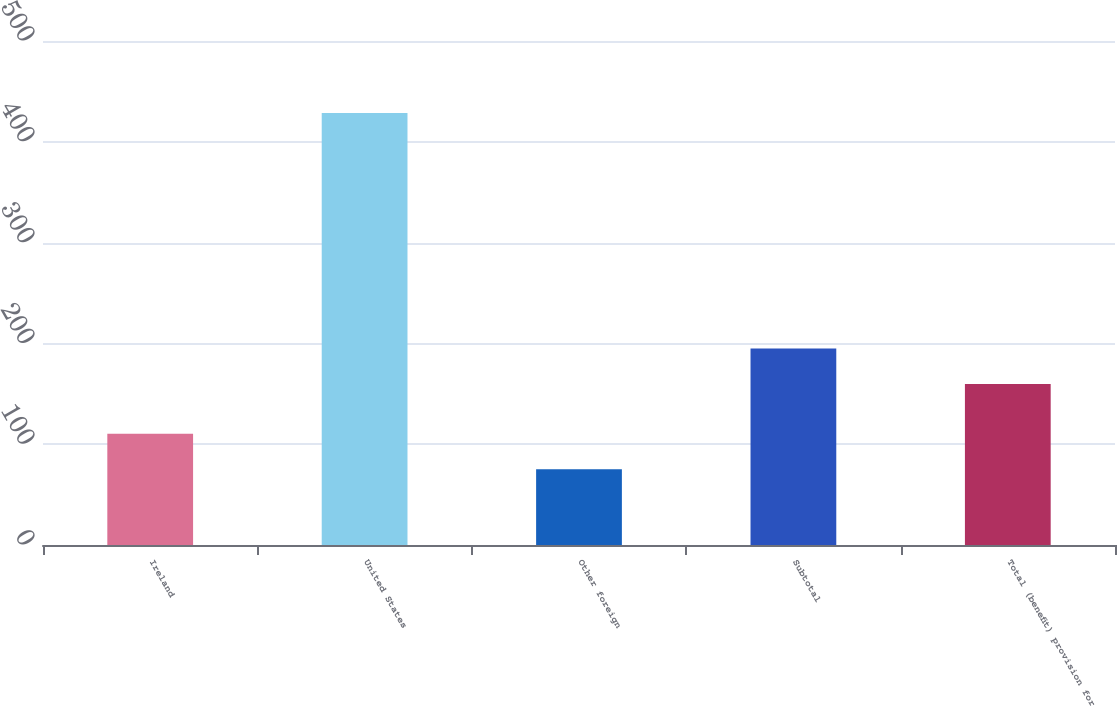<chart> <loc_0><loc_0><loc_500><loc_500><bar_chart><fcel>Ireland<fcel>United States<fcel>Other foreign<fcel>Subtotal<fcel>Total (benefit) provision for<nl><fcel>110.45<fcel>428.6<fcel>75.1<fcel>194.95<fcel>159.6<nl></chart> 